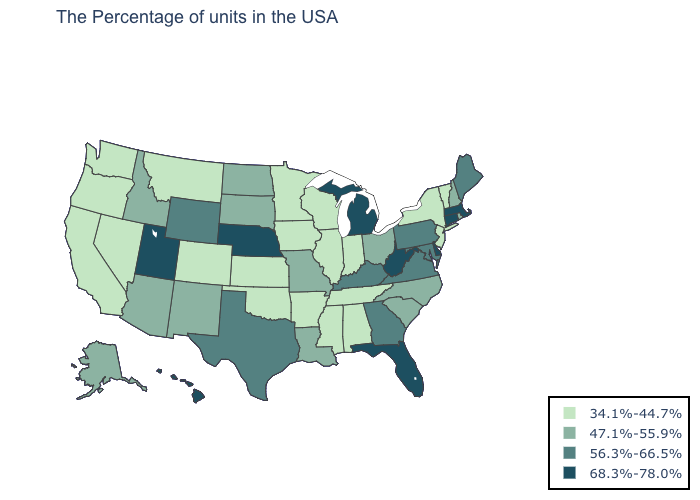What is the value of Mississippi?
Keep it brief. 34.1%-44.7%. Among the states that border Massachusetts , which have the lowest value?
Concise answer only. Vermont, New York. Does Wyoming have a lower value than Connecticut?
Be succinct. Yes. What is the lowest value in the South?
Keep it brief. 34.1%-44.7%. Does Ohio have the same value as Idaho?
Short answer required. Yes. What is the value of Iowa?
Quick response, please. 34.1%-44.7%. Among the states that border West Virginia , which have the highest value?
Give a very brief answer. Maryland, Pennsylvania, Virginia, Kentucky. Which states have the lowest value in the USA?
Concise answer only. Vermont, New York, New Jersey, Indiana, Alabama, Tennessee, Wisconsin, Illinois, Mississippi, Arkansas, Minnesota, Iowa, Kansas, Oklahoma, Colorado, Montana, Nevada, California, Washington, Oregon. What is the value of North Dakota?
Answer briefly. 47.1%-55.9%. How many symbols are there in the legend?
Write a very short answer. 4. Does Oregon have the lowest value in the USA?
Write a very short answer. Yes. Name the states that have a value in the range 56.3%-66.5%?
Write a very short answer. Maine, Maryland, Pennsylvania, Virginia, Georgia, Kentucky, Texas, Wyoming. Among the states that border Virginia , does West Virginia have the highest value?
Short answer required. Yes. Which states have the lowest value in the Northeast?
Write a very short answer. Vermont, New York, New Jersey. 